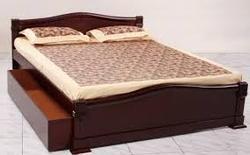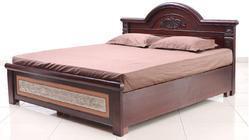The first image is the image on the left, the second image is the image on the right. For the images displayed, is the sentence "Each image shows a bed with non-white pillows on top and a dark head- and foot-board, displayed at an angle." factually correct? Answer yes or no. Yes. The first image is the image on the left, the second image is the image on the right. Analyze the images presented: Is the assertion "The left and right image contains the same number of bed." valid? Answer yes or no. Yes. 